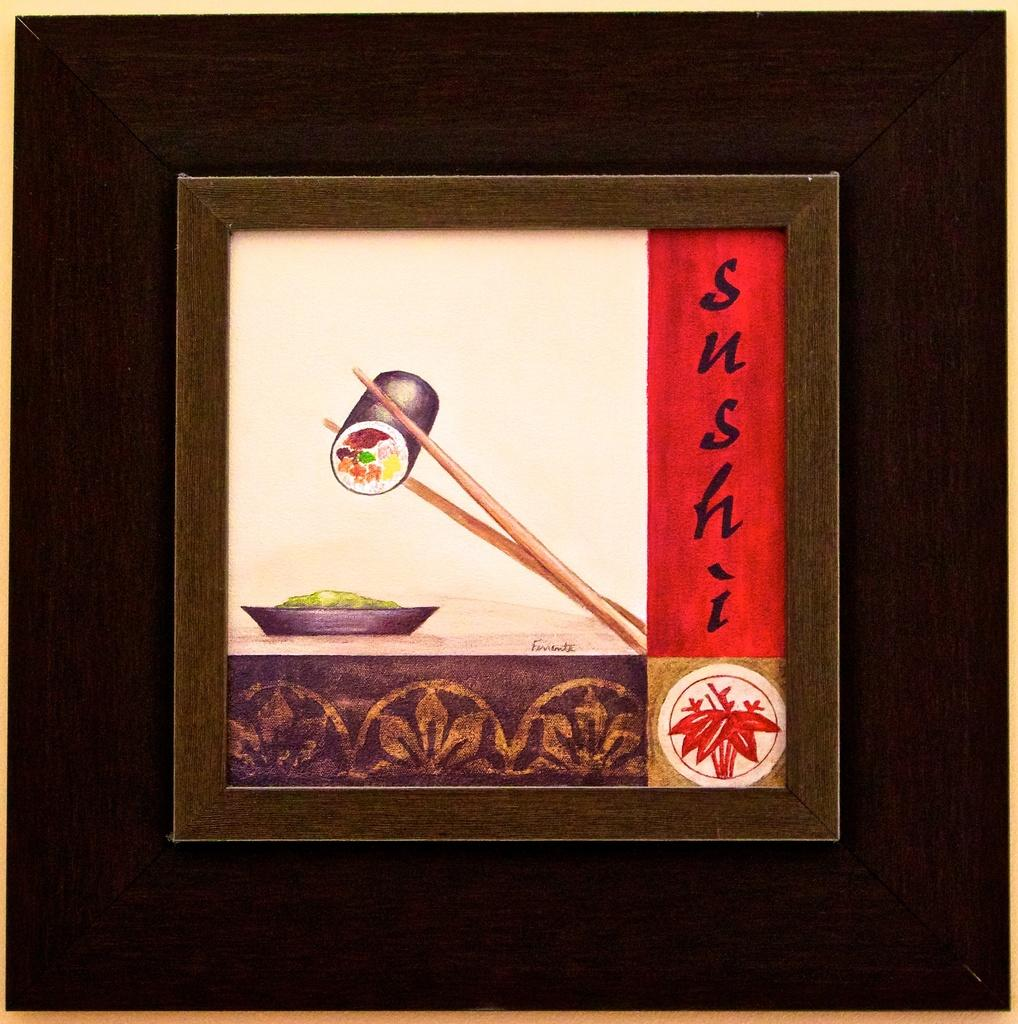What is inside the frame in the image? There is a photograph in the frame. What can be seen on the photograph? Chopsticks and food are present on the photograph. What is the photograph placed on? There is a plate on the photograph. What type of music can be heard coming from the hole in the photograph? There is no hole or music present in the photograph; it is a still image of food and chopsticks on a plate. 